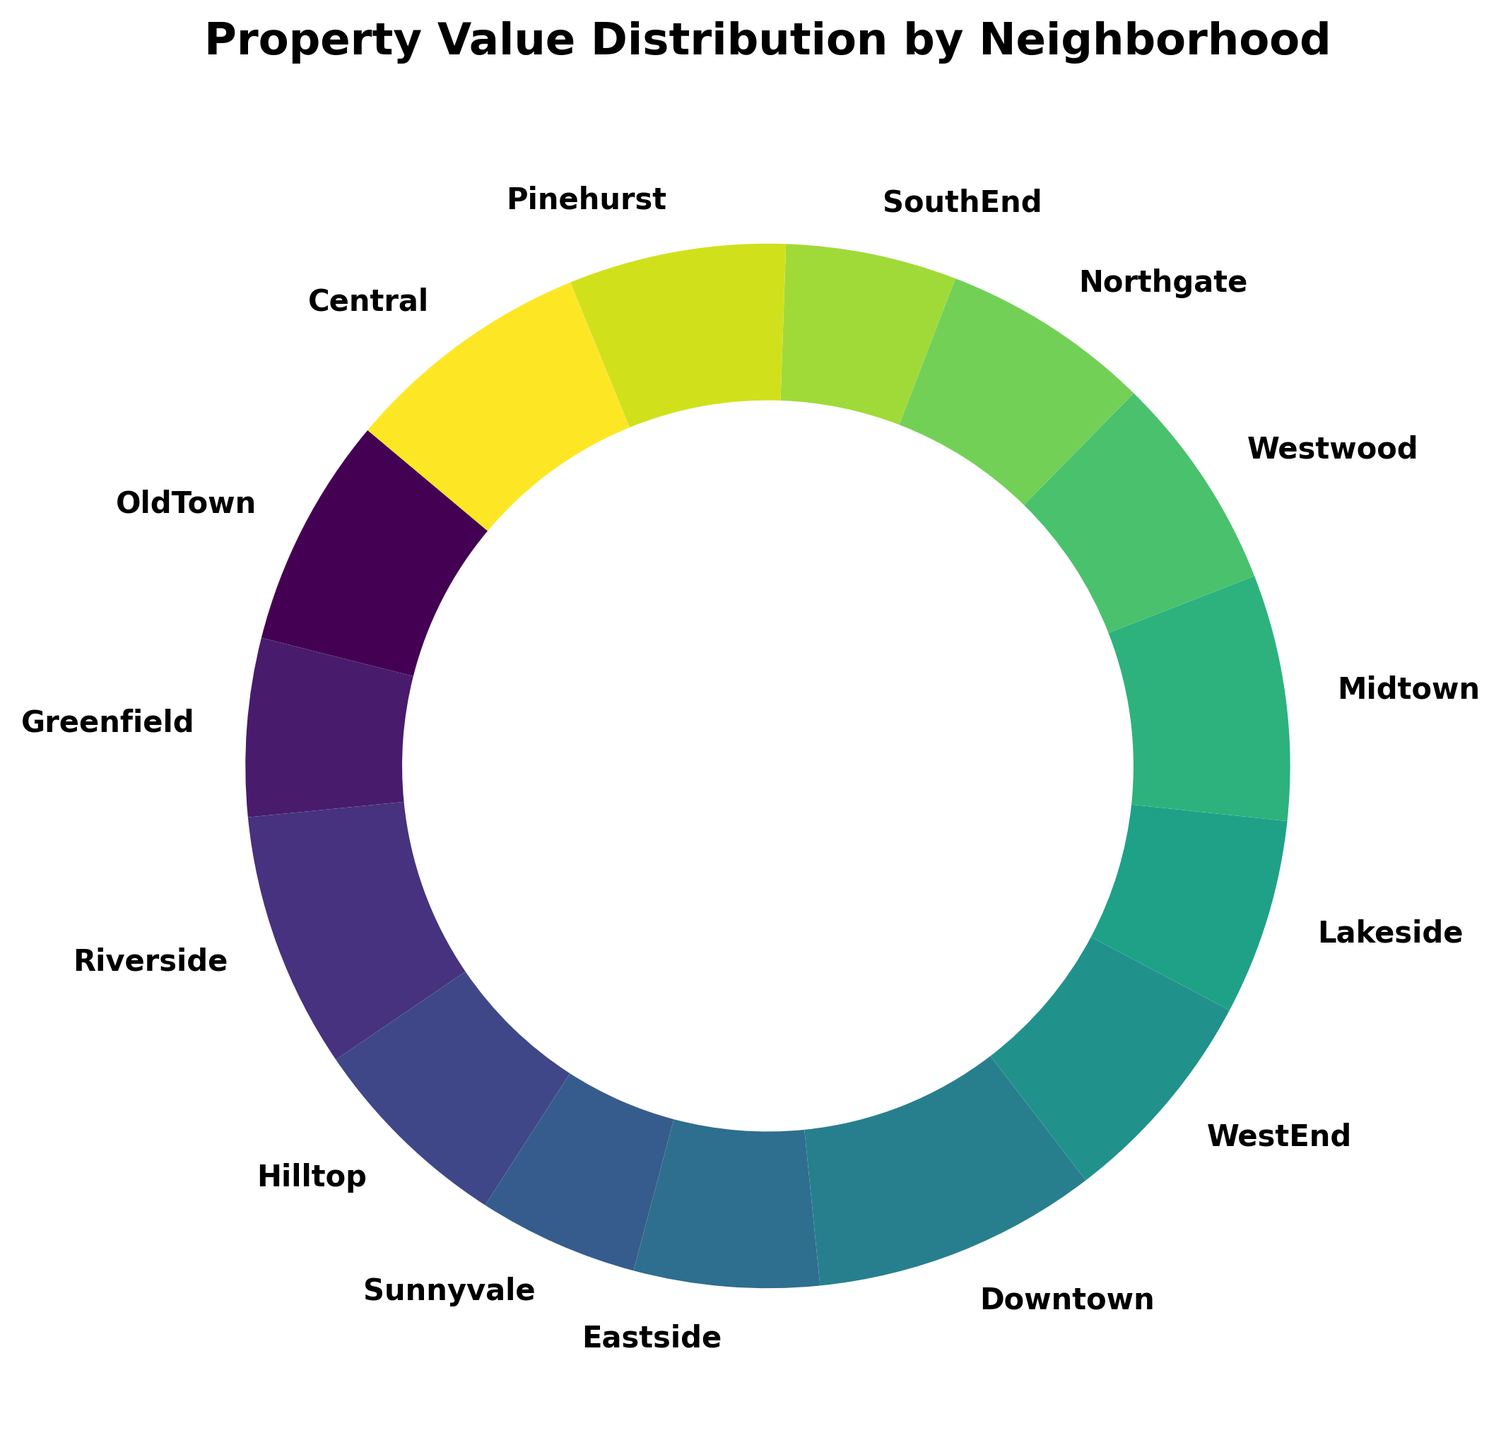What percentage of the total property value is in Downtown? Look at the pie chart and find the segment labeled 'Downtown'. The pie chart should have an associated percentage shown next to Downtown.
Answer: 12.7% Which neighborhood has the highest property value? Identify the segment of the pie chart that represents the largest proportion. Check the corresponding label to see which neighborhood it is.
Answer: Downtown How does the property value of OldTown compare to Sunnyvale? Find OldTown and Sunnyvale on the pie chart. OldTown's property value is represented by a larger segment compared to Sunnyvale, indicating its property value is higher.
Answer: OldTown has a higher property value What is the combined property value percentage of Midtown and Central? Find the segments for Midtown and Central on the pie chart and add their percentages. Midtown shows 11.0% and Central shows 11.2%, so 11.0% + 11.2% = 22.2%.
Answer: 22.2% Which neighborhood has a property value closest to 600,000? Check the segments around the 600,000 marker. Both Westwood and Pinehurst have property values close to 600,000, but the exact value is around 610,000.
Answer: Westwood/Pinehurst Is Hilltop's property value higher than Northgate's? Find the segments for Hilltop and Northgate on the pie chart. Compare their sizes; Hilltop's segment is slightly larger than Northgate's, indicating a higher property value.
Answer: Yes What is the average property value of Greenfield and SouthEnd? Look at the property values for Greenfield (500,000) and SouthEnd (480,000). Calculate the average of these two values: (500,000 + 480,000) / 2 = 490,000.
Answer: 490,000 What is the difference in property value between Eastside and Lakeside? Locate the values for Eastside (520,000) and Lakeside (550,000) in the graph. Calculate the difference: 550,000 - 520,000 = 30,000.
Answer: 30,000 Which neighborhood contributes less than 5% to the total property value? Look at the smallest segments on the pie chart. Sunnyvale, with a percentage less than 5%, contributes the least to the total property value.
Answer: Sunnyvale 